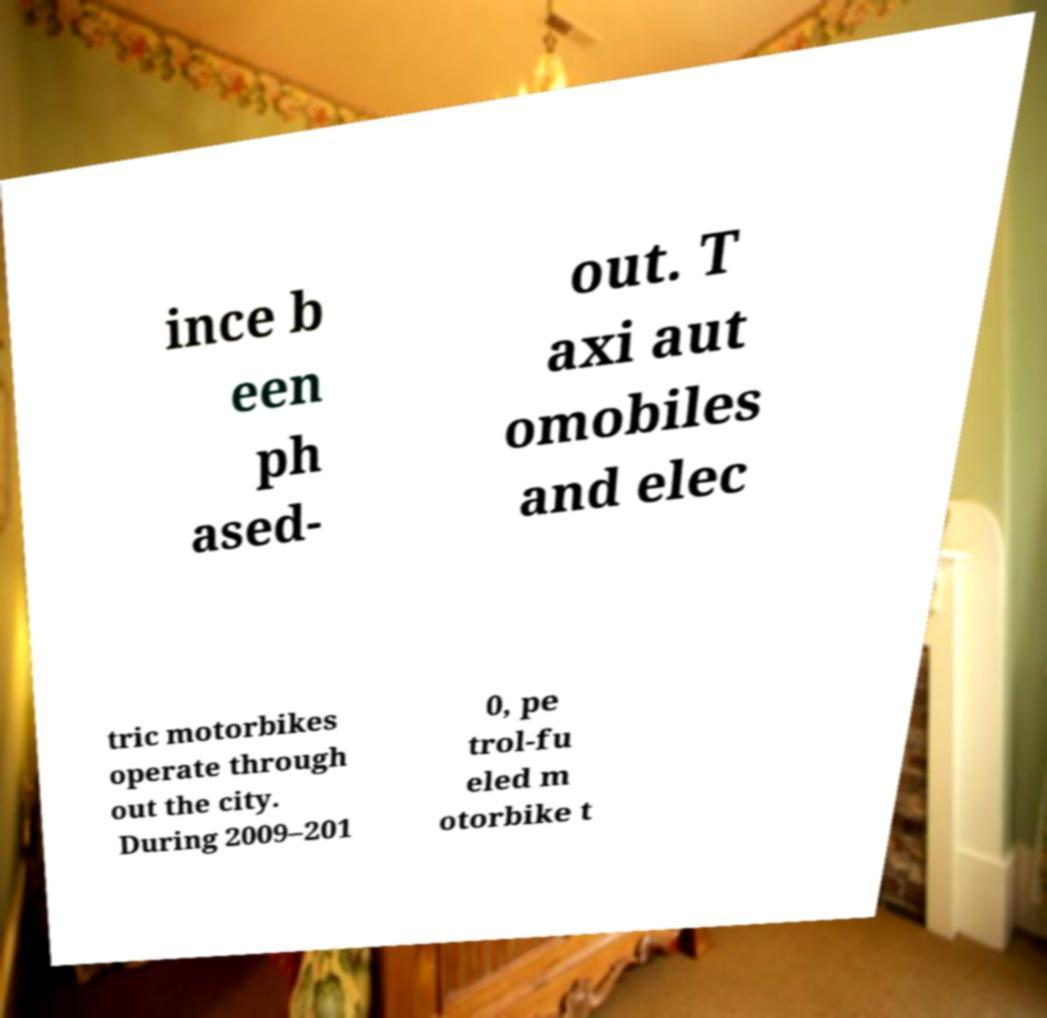Could you assist in decoding the text presented in this image and type it out clearly? ince b een ph ased- out. T axi aut omobiles and elec tric motorbikes operate through out the city. During 2009–201 0, pe trol-fu eled m otorbike t 